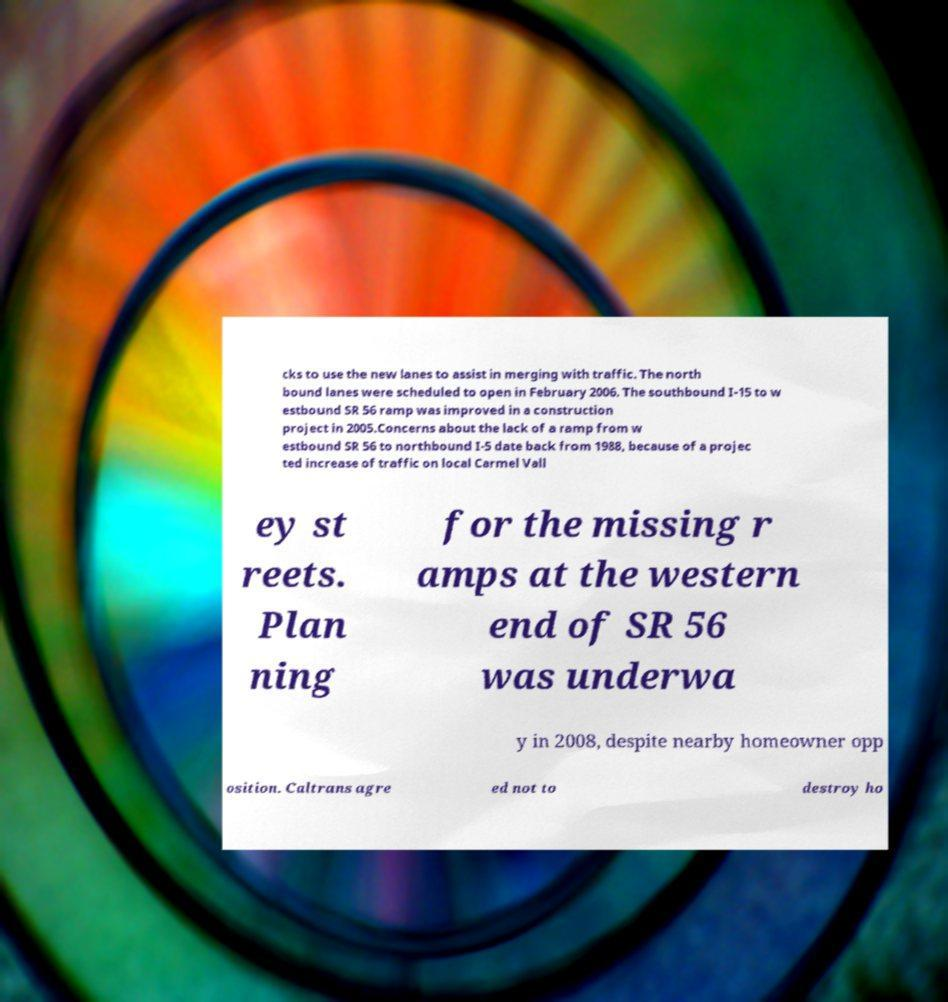There's text embedded in this image that I need extracted. Can you transcribe it verbatim? cks to use the new lanes to assist in merging with traffic. The north bound lanes were scheduled to open in February 2006. The southbound I-15 to w estbound SR 56 ramp was improved in a construction project in 2005.Concerns about the lack of a ramp from w estbound SR 56 to northbound I-5 date back from 1988, because of a projec ted increase of traffic on local Carmel Vall ey st reets. Plan ning for the missing r amps at the western end of SR 56 was underwa y in 2008, despite nearby homeowner opp osition. Caltrans agre ed not to destroy ho 